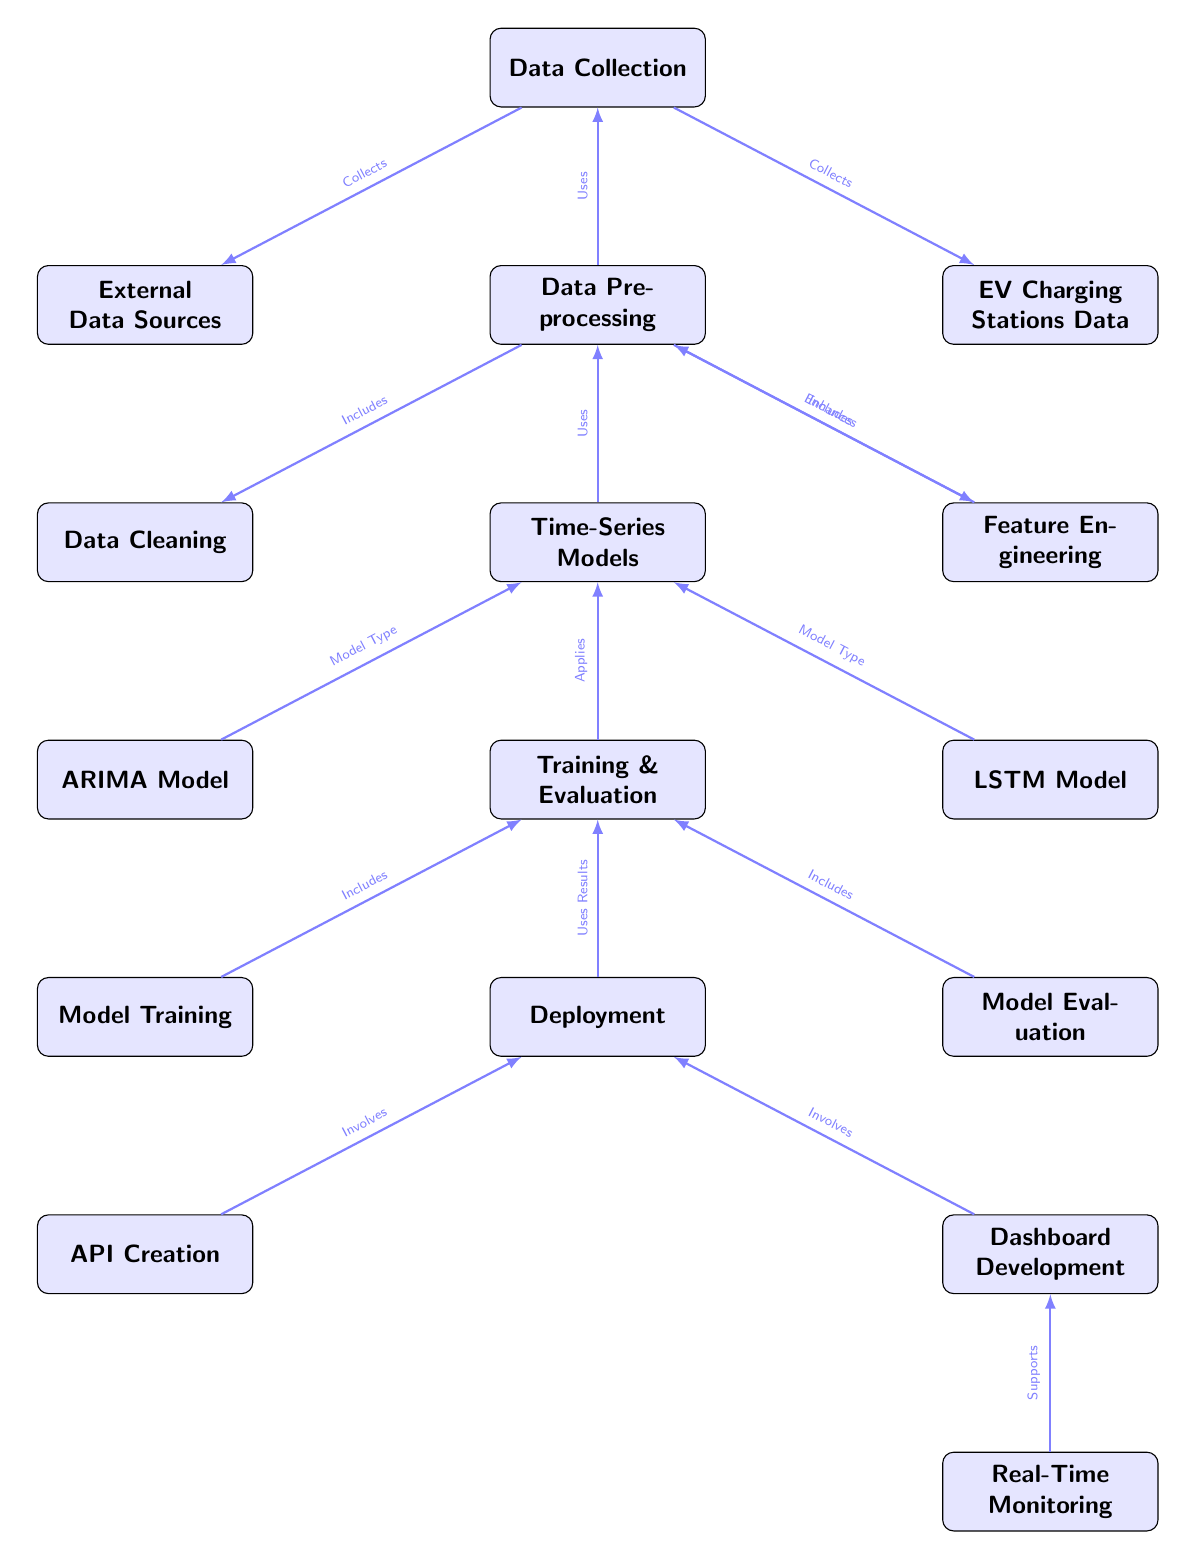What are the two sources of data collection shown in the diagram? The diagram displays two sources of data collection: "EV Charging Stations Data" and "External Data Sources," both of which are collected through the "Data Collection" node.
Answer: EV Charging Stations Data, External Data Sources What is the primary purpose of the "Data Preprocessing" node? The "Data Preprocessing" node serves to prepare the collected data for analysis, involving tasks such as "Data Cleaning" and "Feature Engineering," both of which are included in its processes as shown.
Answer: Prepare data for analysis How many different "Time-Series Models" are represented in the diagram? The diagram features two distinct "Time-Series Models," namely the "ARIMA Model" and the "LSTM Model," as indicated by the connections to the "Time-Series Models" node.
Answer: Two What role does the "Real-Time Monitoring" node play in relation to the diagram? The "Real-Time Monitoring" node is positioned at the end of the flow, indicating that it supports the "Dashboard Development," ensuring ongoing visibility into the relevant metrics generated by the model outputs.
Answer: Supports Dashboard Development Which model type is categorized under "Time-Series Models" in the diagram? The diagram categorizes "ARIMA Model" and "LSTM Model" under the "Time-Series Models," both of which are specified as model types utilized in the forecasting process.
Answer: ARIMA Model, LSTM Model What process directly precedes the "Deployment" node? The "Deployment" node follows the "Training & Evaluation" node, indicating that it relies on the results produced from both training and evaluating the models before implementation.
Answer: Training & Evaluation Which node is responsible for data cleaning? The "Data Cleaning" node is included under the "Data Preprocessing," indicating that it plays a critical role in ensuring the integrity and quality of the data utilized for model training.
Answer: Data Cleaning How is the relationship between "API Creation" and "Dashboard Development" represented in the diagram? Both "API Creation" and "Dashboard Development" are depicted as parts of the "Deployment" process, indicating that they are components that contribute to the overall deployment strategy and functionality.
Answer: Involves Deployment 